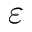Convert formula to latex. <formula><loc_0><loc_0><loc_500><loc_500>\varepsilon</formula> 